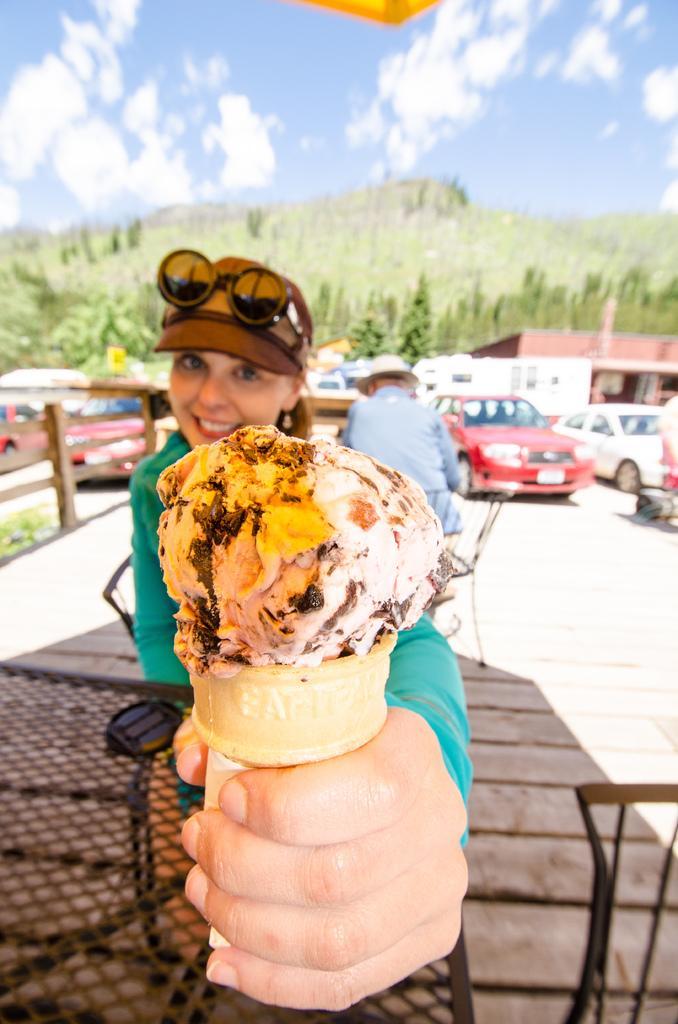How would you summarize this image in a sentence or two? This picture is clicked outside. In the foreground we can see a person holding an ice cream, smiling and seems to be sitting and we can see the mesh and some metal objects. In the background we can see a person seems to be sitting and we can see the group of vehicles, houses, trees, sky with the clouds and some other objects. 